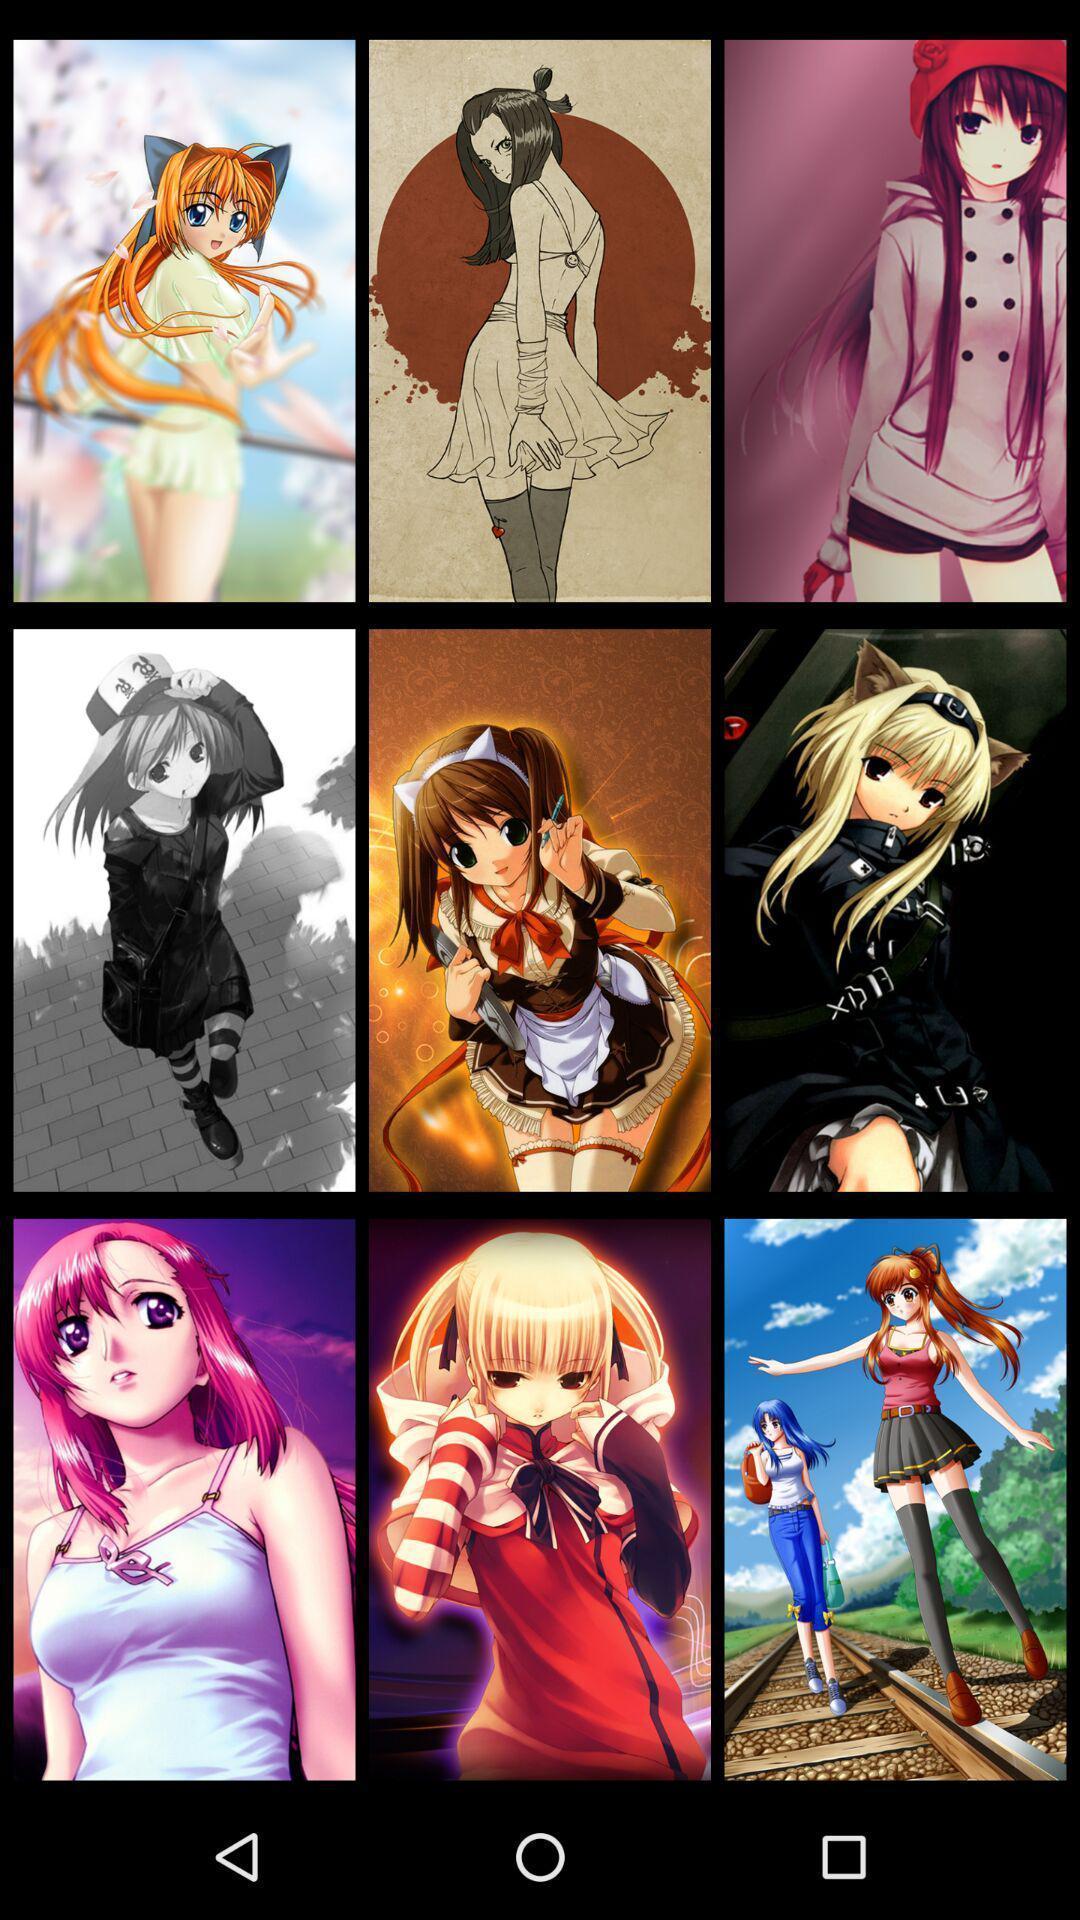Describe the visual elements of this screenshot. Screen showing the images in app. 